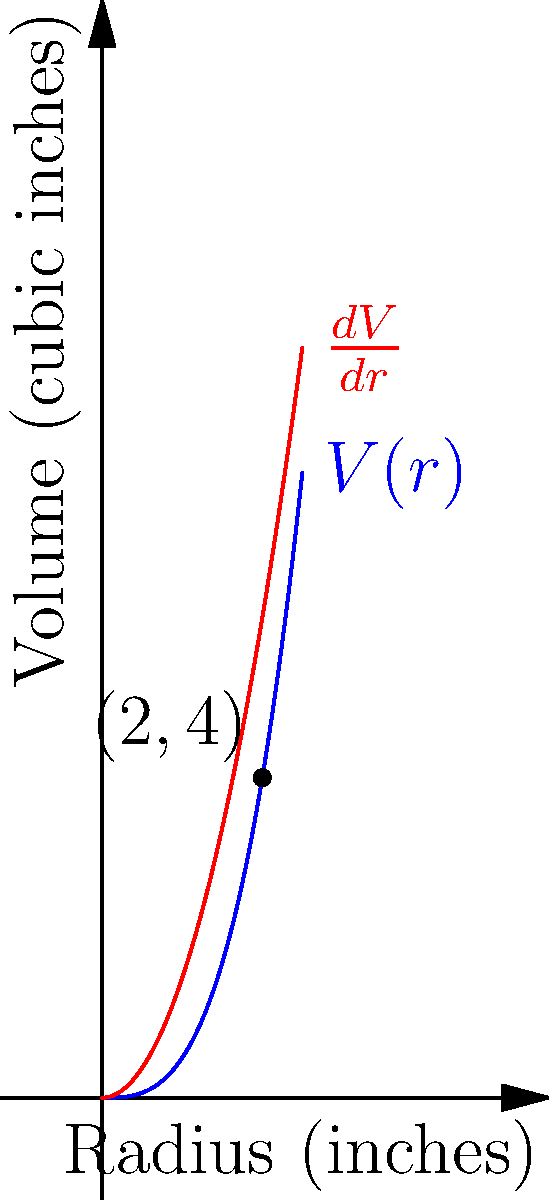A classical music vinyl record is spinning on a turntable. The volume $V$ of the record (in cubic inches) as a function of its radius $r$ (in inches) is given by $V(r) = \frac{1}{2}r^3$. At what rate is the volume changing when the radius is 2 inches? To find the rate of change of volume with respect to radius, we need to follow these steps:

1) The volume function is given as $V(r) = \frac{1}{2}r^3$.

2) To find the rate of change, we need to differentiate $V(r)$ with respect to $r$:

   $\frac{dV}{dr} = \frac{d}{dr}(\frac{1}{2}r^3)$

3) Using the power rule of differentiation:

   $\frac{dV}{dr} = \frac{1}{2} \cdot 3r^2 = \frac{3}{2}r^2$

4) Now, we need to evaluate this at $r = 2$ inches:

   $\frac{dV}{dr}\big|_{r=2} = \frac{3}{2}(2)^2 = \frac{3}{2} \cdot 4 = 6$

5) Therefore, when the radius is 2 inches, the volume is changing at a rate of 6 cubic inches per inch of radius.

The blue curve in the graph represents $V(r)$, while the red curve represents $\frac{dV}{dr}$. The point (2,4) on the blue curve corresponds to the volume when $r=2$, and the height of the red curve at $r=2$ gives the rate of change of volume at that point.
Answer: 6 cubic inches per inch 